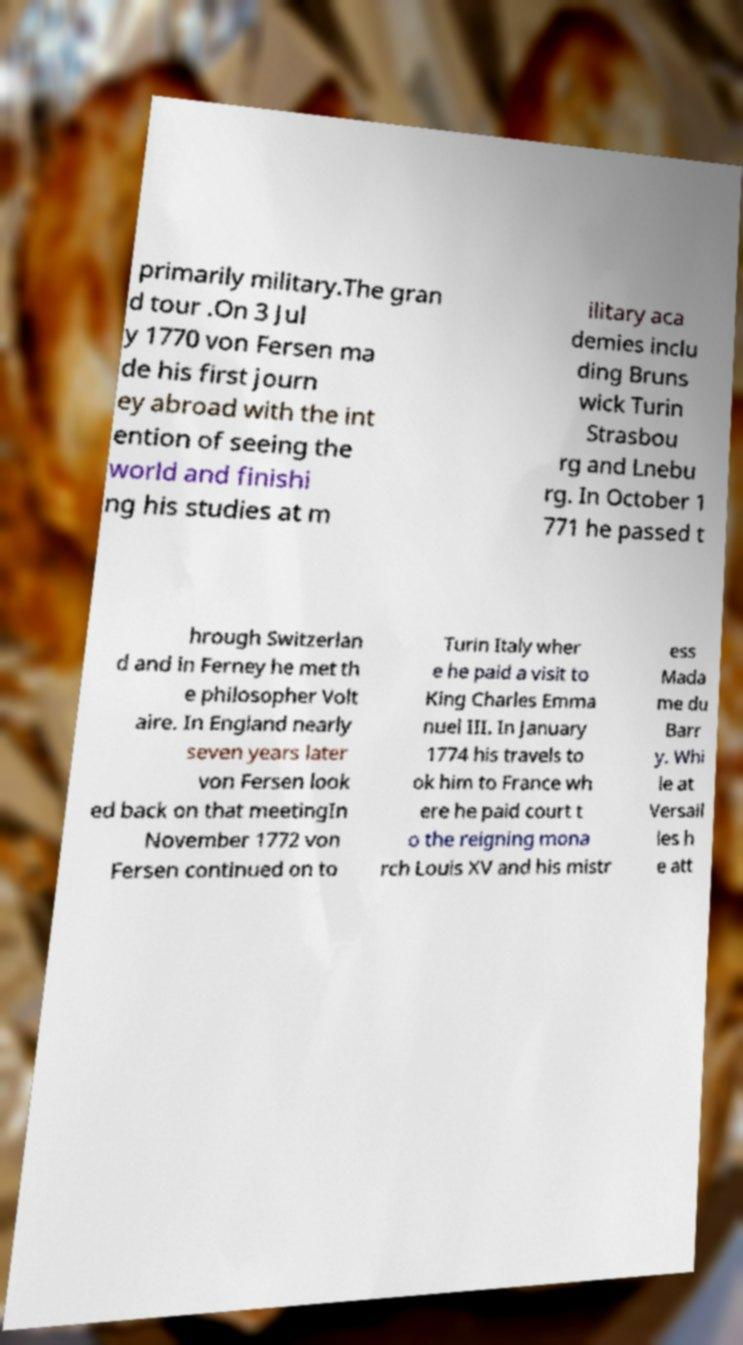For documentation purposes, I need the text within this image transcribed. Could you provide that? primarily military.The gran d tour .On 3 Jul y 1770 von Fersen ma de his first journ ey abroad with the int ention of seeing the world and finishi ng his studies at m ilitary aca demies inclu ding Bruns wick Turin Strasbou rg and Lnebu rg. In October 1 771 he passed t hrough Switzerlan d and in Ferney he met th e philosopher Volt aire. In England nearly seven years later von Fersen look ed back on that meetingIn November 1772 von Fersen continued on to Turin Italy wher e he paid a visit to King Charles Emma nuel III. In January 1774 his travels to ok him to France wh ere he paid court t o the reigning mona rch Louis XV and his mistr ess Mada me du Barr y. Whi le at Versail les h e att 